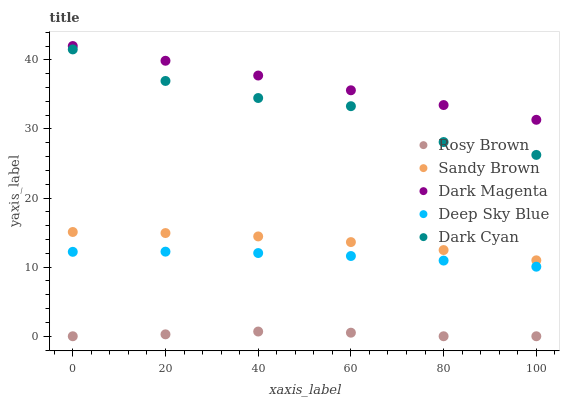Does Rosy Brown have the minimum area under the curve?
Answer yes or no. Yes. Does Dark Magenta have the maximum area under the curve?
Answer yes or no. Yes. Does Sandy Brown have the minimum area under the curve?
Answer yes or no. No. Does Sandy Brown have the maximum area under the curve?
Answer yes or no. No. Is Dark Magenta the smoothest?
Answer yes or no. Yes. Is Dark Cyan the roughest?
Answer yes or no. Yes. Is Rosy Brown the smoothest?
Answer yes or no. No. Is Rosy Brown the roughest?
Answer yes or no. No. Does Rosy Brown have the lowest value?
Answer yes or no. Yes. Does Sandy Brown have the lowest value?
Answer yes or no. No. Does Dark Magenta have the highest value?
Answer yes or no. Yes. Does Sandy Brown have the highest value?
Answer yes or no. No. Is Dark Cyan less than Dark Magenta?
Answer yes or no. Yes. Is Dark Cyan greater than Sandy Brown?
Answer yes or no. Yes. Does Dark Cyan intersect Dark Magenta?
Answer yes or no. No. 